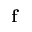Convert formula to latex. <formula><loc_0><loc_0><loc_500><loc_500>f</formula> 